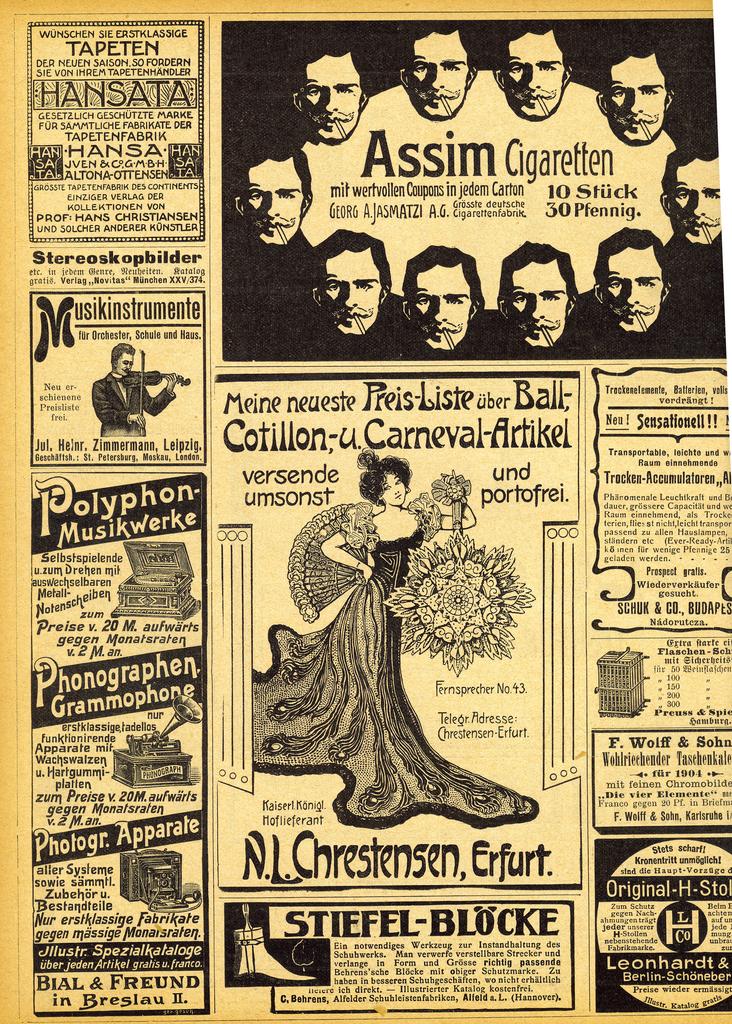What is the name of the men in a circle?
Your answer should be compact. Assim cigaretten. What are the first two words of the ad in the center of the page?
Ensure brevity in your answer.  Meine neueste. 